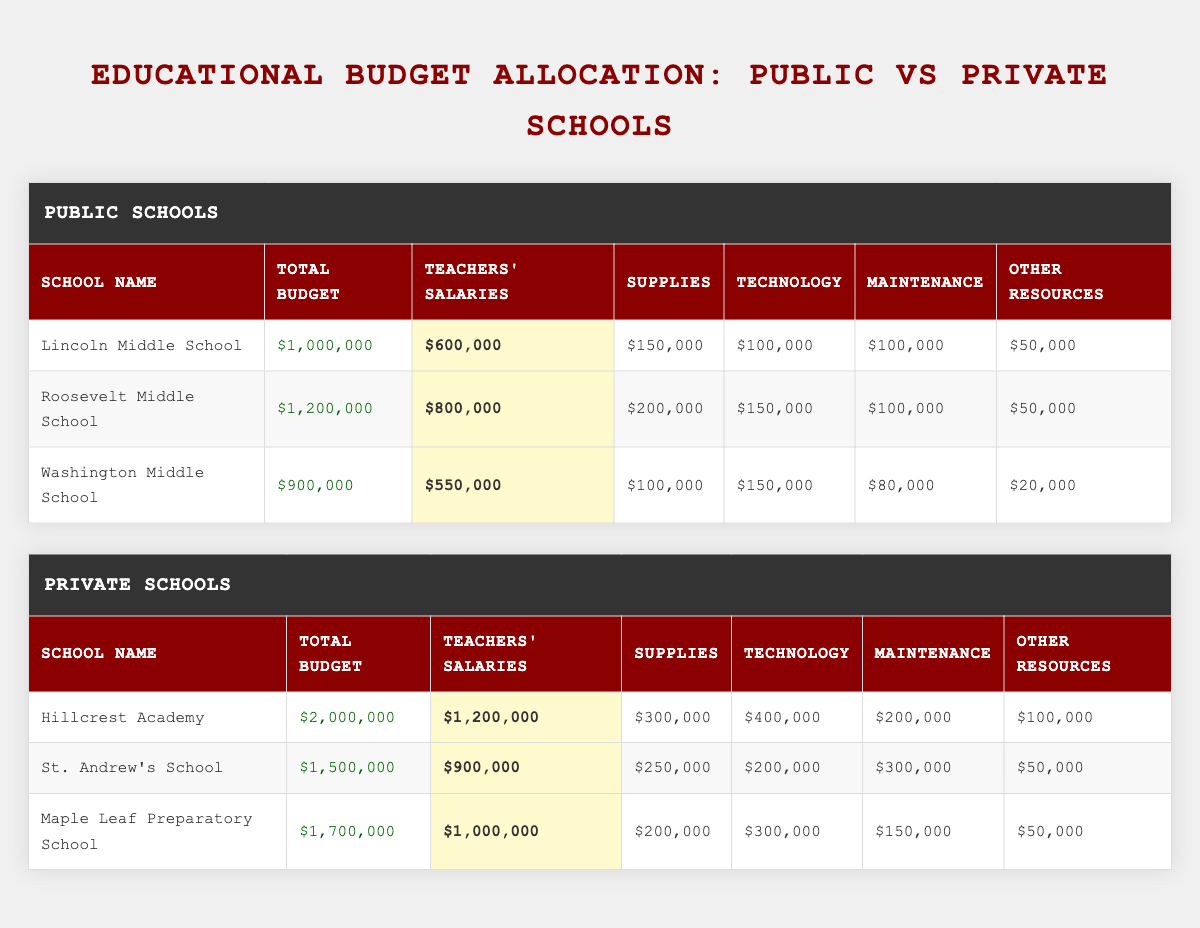What's the total budget for Lincoln Middle School? The table lists Lincoln Middle School under public schools, and its total budget is indicated as $1,000,000.
Answer: $1,000,000 Which private school has the highest allocation for teachers' salaries? Looking through the private schools' allocations, Hillcrest Academy has the highest allocation for teachers' salaries at $1,200,000.
Answer: Hillcrest Academy What is the combined total budget for all public schools listed? The total budget for public schools is found by summing the individual budgets: $1,000,000 (Lincoln) + $1,200,000 (Roosevelt) + $900,000 (Washington) = $3,100,000.
Answer: $3,100,000 Is the technology budget higher for any public school compared to the technology budget of Maple Leaf Preparatory School? Maple Leaf Preparatory School has a technology budget of $300,000. Washington Middle School’s technology budget is $150,000, Lincoln’s is $100,000, and Roosevelt’s is $150,000, none of which exceed $300,000. Therefore, no public school has a higher budget for technology compared to Maple Leaf Preparatory School.
Answer: No What is the average allocation for supplies in public schools? The allocation for supplies in public schools is $150,000 (Lincoln) + $200,000 (Roosevelt) + $100,000 (Washington) = $450,000. There are 3 public schools, so the average is $450,000 / 3 = $150,000.
Answer: $150,000 Does St. Andrew's School allocate the same amount on supplies and maintenance? St. Andrew's School allocates $250,000 for supplies and $300,000 for maintenance, which are not equal.
Answer: No What is the ratio of teachers’ salaries to the total budget for all private schools combined? The total budget for private schools is $2,000,000 (Hillcrest) + $1,500,000 (St. Andrew's) + $1,700,000 (Maple Leaf) = $5,200,000. The total allocation for teachers' salaries in private schools is $1,200,000 (Hillcrest) + $900,000 (St. Andrew's) + $1,000,000 (Maple Leaf) = $3,100,000. Therefore, the ratio is $3,100,000 : $5,200,000, which simplifies to 31 : 52 or approximately 0.6.
Answer: 0.6 Which school has the highest total budget? Among the schools listed, Hillcrest Academy has the highest total budget of $2,000,000.
Answer: Hillcrest Academy What percentage of Lincoln Middle School's total budget is spent on other resources? Lincoln Middle School spends $50,000 on other resources out of a total budget of $1,000,000. The percentage is calculated as ($50,000 / $1,000,000) * 100 = 5%.
Answer: 5% Which public school has the smallest allocation for technology? Among public schools, Lincoln Middle School has the smallest allocation for technology at $100,000.
Answer: Lincoln Middle School 